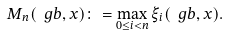Convert formula to latex. <formula><loc_0><loc_0><loc_500><loc_500>M _ { n } ( \ g b , x ) \colon = \max _ { 0 \leq i < n } \xi _ { i } ( \ g b , x ) .</formula> 